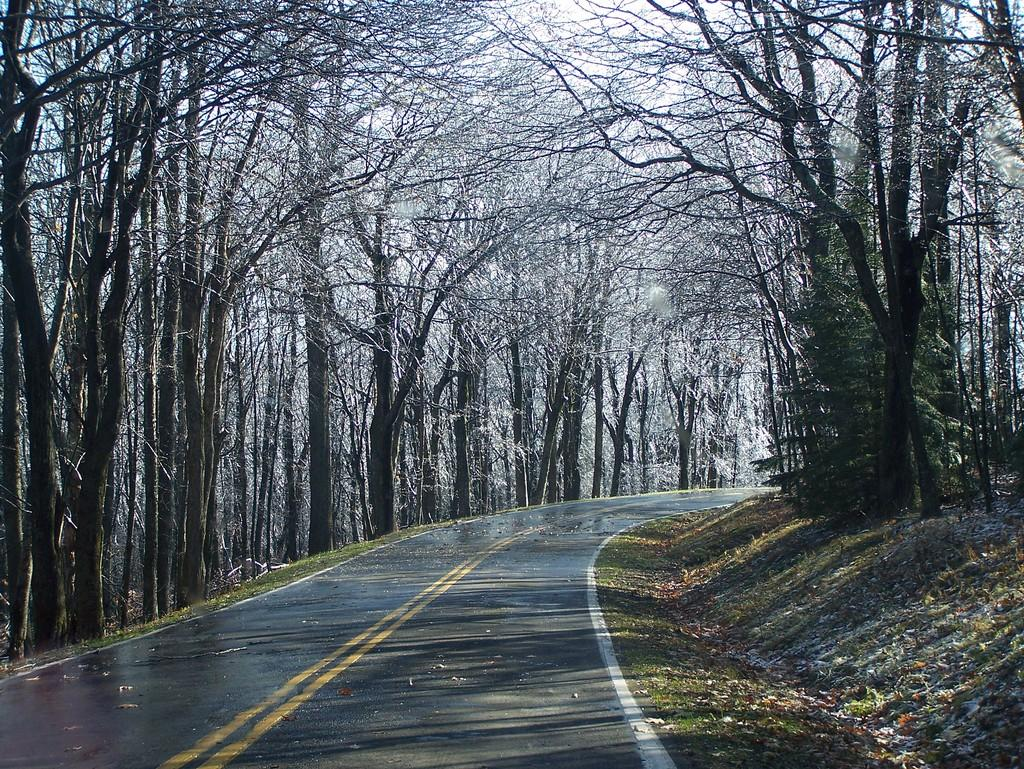What is located at the bottom of the image? The road is at the bottom of the image. What is the condition of the road in the image? The road appears to be wet in the image. What type of vegetation is present on either side of the road? There are trees on either side of the road. What can be seen on the right side of the image? Dried leaves are present on the right side of the image. Are there any beginner cats playing with the dried leaves in the image? There is no mention of cats, let alone beginner cats, in the image. The image only features a wet road with trees on either side and dried leaves on the right side. 